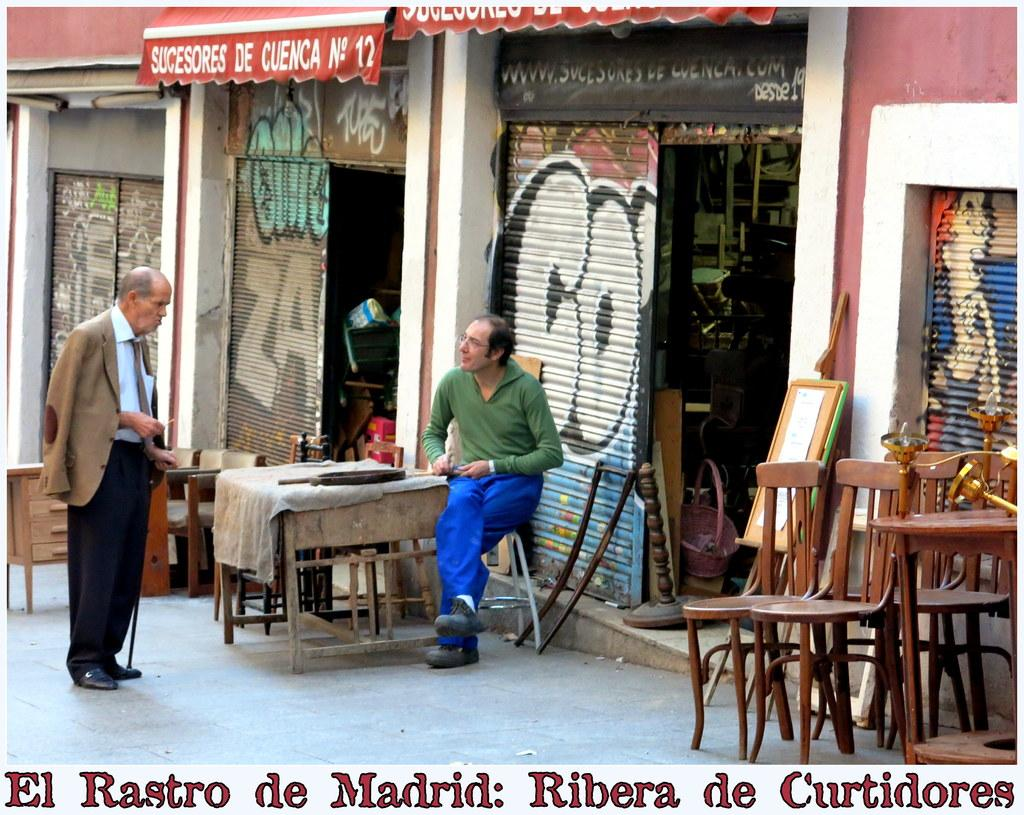How many men are present in the image? There are two men in the image. What are the positions of the men in the image? One man is standing, and the other man is sitting on a chair. What is in front of the men? The two men are in front of a table. What can be seen in the background of the image? Stores are visible in the background of the image. What type of glass is the man holding in the image? There is no glass present in the image; both men are empty-handed. 